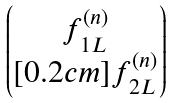Convert formula to latex. <formula><loc_0><loc_0><loc_500><loc_500>\begin{pmatrix} f _ { 1 L } ^ { ( n ) } \\ [ 0 . 2 c m ] f _ { 2 L } ^ { ( n ) } \end{pmatrix}</formula> 